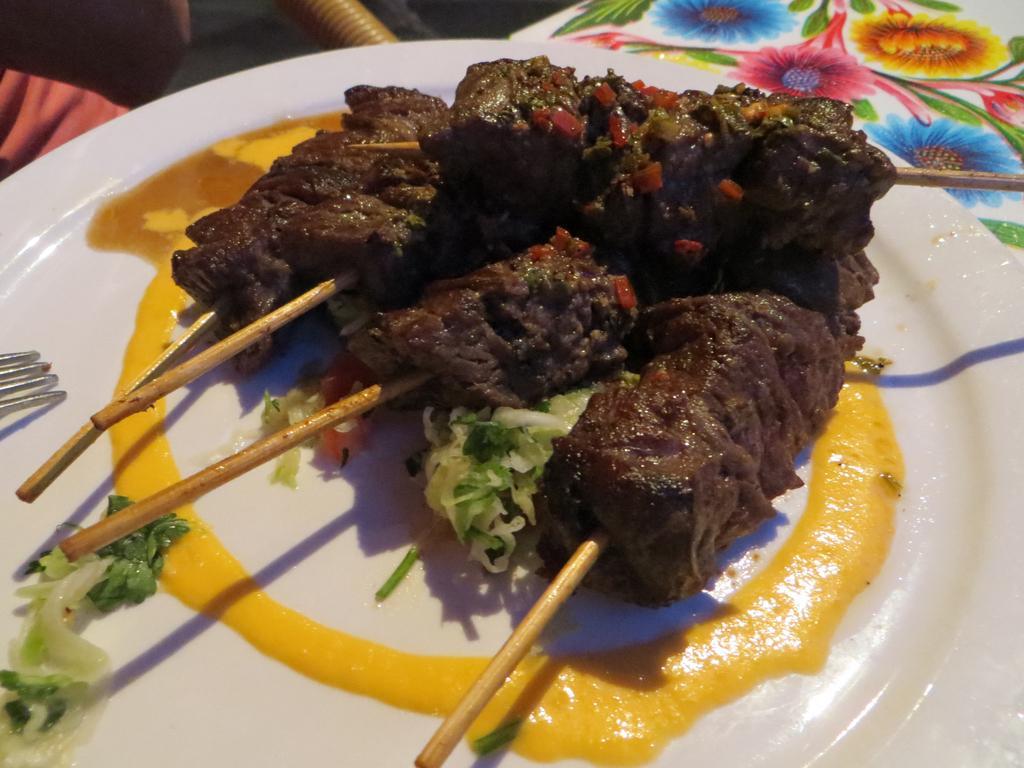Could you give a brief overview of what you see in this image? In this image we can see some food items on a plate, it is placed on the surface of the table, which has a floral print on it. 